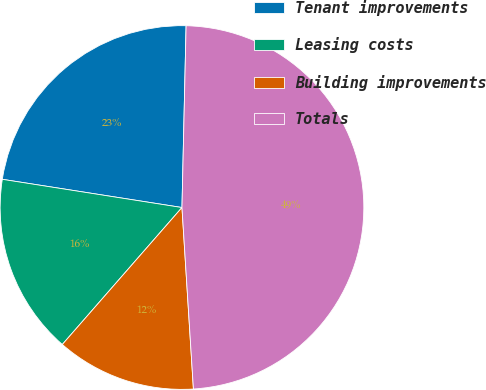<chart> <loc_0><loc_0><loc_500><loc_500><pie_chart><fcel>Tenant improvements<fcel>Leasing costs<fcel>Building improvements<fcel>Totals<nl><fcel>22.88%<fcel>16.05%<fcel>12.43%<fcel>48.63%<nl></chart> 